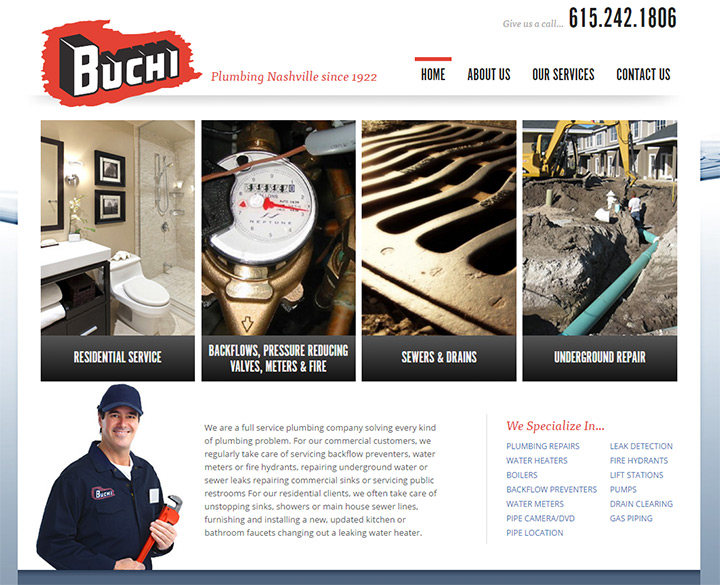Considering the historical claim of the company serving since 1922, what aspects of the website suggest modernity or adherence to contemporary web design standards? The website exemplifies modernity and adherence to contemporary web design standards through several key aspects. Firstly, the clean and organized layout, with well-defined sections and a balanced use of white space, facilitates easy navigation and readability. High-quality images prominently displayed add a visually appealing element, showcasing the services offered effectively, which is a hallmark of modern web design. The navigation bar at the top with clear and intuitive links to different sections of the website ensures a seamless user experience. Additionally, the presence of a prominent contact number at the top of the page is a practical feature that caters to user convenience, suggesting a professional and customer-oriented approach. The modern design is also reflected in the use of responsive elements that adapt to different devices, ensuring a consistent and pleasant browsing experience. Overall, the website successfully integrates elements of modern web design with its historical brand identity. 